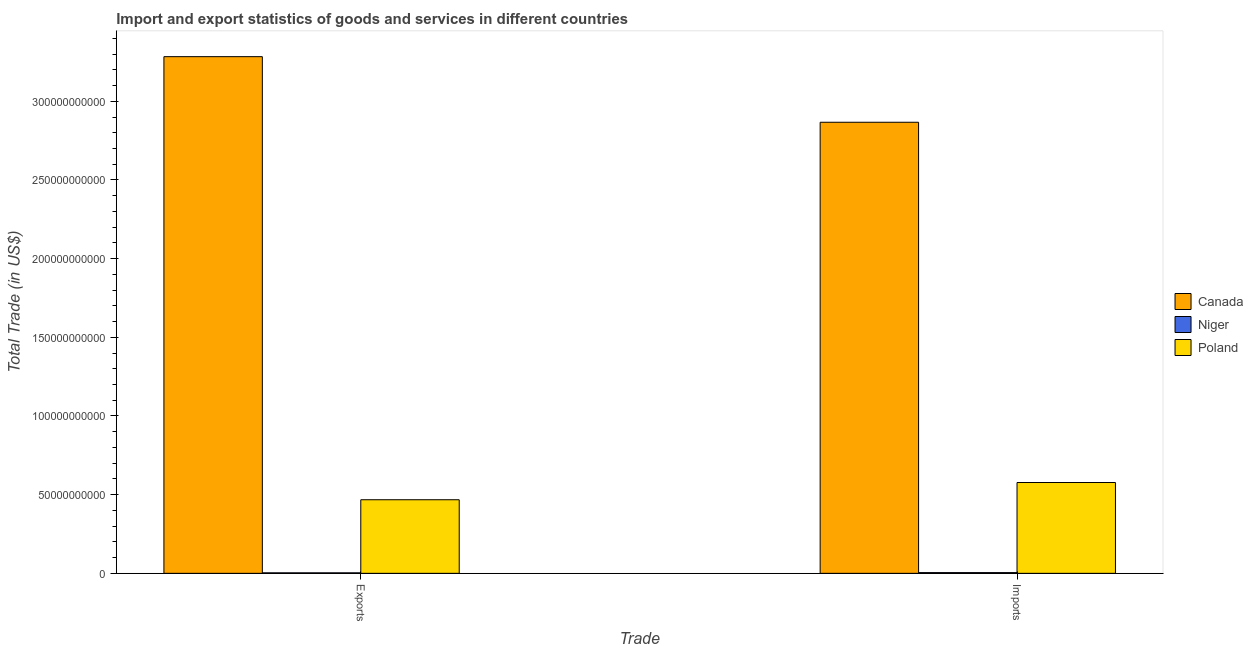How many different coloured bars are there?
Your answer should be very brief. 3. How many groups of bars are there?
Your answer should be compact. 2. How many bars are there on the 1st tick from the right?
Offer a terse response. 3. What is the label of the 1st group of bars from the left?
Keep it short and to the point. Exports. What is the imports of goods and services in Poland?
Your answer should be compact. 5.77e+1. Across all countries, what is the maximum export of goods and services?
Provide a short and direct response. 3.28e+11. Across all countries, what is the minimum imports of goods and services?
Offer a very short reply. 4.62e+08. In which country was the export of goods and services minimum?
Make the answer very short. Niger. What is the total imports of goods and services in the graph?
Your answer should be very brief. 3.45e+11. What is the difference between the export of goods and services in Poland and that in Niger?
Offer a very short reply. 4.65e+1. What is the difference between the imports of goods and services in Poland and the export of goods and services in Canada?
Provide a short and direct response. -2.71e+11. What is the average export of goods and services per country?
Your response must be concise. 1.25e+11. What is the difference between the export of goods and services and imports of goods and services in Canada?
Your answer should be compact. 4.17e+1. What is the ratio of the imports of goods and services in Niger to that in Poland?
Your answer should be very brief. 0.01. In how many countries, is the imports of goods and services greater than the average imports of goods and services taken over all countries?
Your answer should be very brief. 1. What does the 3rd bar from the left in Exports represents?
Keep it short and to the point. Poland. What does the 1st bar from the right in Exports represents?
Make the answer very short. Poland. How many bars are there?
Keep it short and to the point. 6. Are all the bars in the graph horizontal?
Offer a very short reply. No. How many countries are there in the graph?
Keep it short and to the point. 3. Are the values on the major ticks of Y-axis written in scientific E-notation?
Offer a terse response. No. Does the graph contain any zero values?
Provide a succinct answer. No. Where does the legend appear in the graph?
Provide a short and direct response. Center right. How many legend labels are there?
Offer a terse response. 3. What is the title of the graph?
Provide a short and direct response. Import and export statistics of goods and services in different countries. What is the label or title of the X-axis?
Your answer should be compact. Trade. What is the label or title of the Y-axis?
Provide a short and direct response. Total Trade (in US$). What is the Total Trade (in US$) of Canada in Exports?
Provide a succinct answer. 3.28e+11. What is the Total Trade (in US$) in Niger in Exports?
Your answer should be compact. 3.20e+08. What is the Total Trade (in US$) of Poland in Exports?
Give a very brief answer. 4.68e+1. What is the Total Trade (in US$) of Canada in Imports?
Offer a very short reply. 2.87e+11. What is the Total Trade (in US$) of Niger in Imports?
Offer a terse response. 4.62e+08. What is the Total Trade (in US$) of Poland in Imports?
Keep it short and to the point. 5.77e+1. Across all Trade, what is the maximum Total Trade (in US$) in Canada?
Your answer should be compact. 3.28e+11. Across all Trade, what is the maximum Total Trade (in US$) in Niger?
Offer a very short reply. 4.62e+08. Across all Trade, what is the maximum Total Trade (in US$) of Poland?
Your answer should be compact. 5.77e+1. Across all Trade, what is the minimum Total Trade (in US$) in Canada?
Provide a succinct answer. 2.87e+11. Across all Trade, what is the minimum Total Trade (in US$) of Niger?
Offer a very short reply. 3.20e+08. Across all Trade, what is the minimum Total Trade (in US$) in Poland?
Provide a succinct answer. 4.68e+1. What is the total Total Trade (in US$) in Canada in the graph?
Keep it short and to the point. 6.15e+11. What is the total Total Trade (in US$) of Niger in the graph?
Give a very brief answer. 7.82e+08. What is the total Total Trade (in US$) of Poland in the graph?
Provide a short and direct response. 1.04e+11. What is the difference between the Total Trade (in US$) of Canada in Exports and that in Imports?
Ensure brevity in your answer.  4.17e+1. What is the difference between the Total Trade (in US$) of Niger in Exports and that in Imports?
Offer a very short reply. -1.42e+08. What is the difference between the Total Trade (in US$) of Poland in Exports and that in Imports?
Ensure brevity in your answer.  -1.09e+1. What is the difference between the Total Trade (in US$) of Canada in Exports and the Total Trade (in US$) of Niger in Imports?
Provide a succinct answer. 3.28e+11. What is the difference between the Total Trade (in US$) in Canada in Exports and the Total Trade (in US$) in Poland in Imports?
Your answer should be compact. 2.71e+11. What is the difference between the Total Trade (in US$) of Niger in Exports and the Total Trade (in US$) of Poland in Imports?
Your response must be concise. -5.74e+1. What is the average Total Trade (in US$) in Canada per Trade?
Provide a short and direct response. 3.08e+11. What is the average Total Trade (in US$) in Niger per Trade?
Offer a terse response. 3.91e+08. What is the average Total Trade (in US$) of Poland per Trade?
Offer a very short reply. 5.22e+1. What is the difference between the Total Trade (in US$) of Canada and Total Trade (in US$) of Niger in Exports?
Your response must be concise. 3.28e+11. What is the difference between the Total Trade (in US$) of Canada and Total Trade (in US$) of Poland in Exports?
Offer a very short reply. 2.82e+11. What is the difference between the Total Trade (in US$) in Niger and Total Trade (in US$) in Poland in Exports?
Your response must be concise. -4.65e+1. What is the difference between the Total Trade (in US$) of Canada and Total Trade (in US$) of Niger in Imports?
Ensure brevity in your answer.  2.86e+11. What is the difference between the Total Trade (in US$) in Canada and Total Trade (in US$) in Poland in Imports?
Your answer should be compact. 2.29e+11. What is the difference between the Total Trade (in US$) of Niger and Total Trade (in US$) of Poland in Imports?
Make the answer very short. -5.73e+1. What is the ratio of the Total Trade (in US$) of Canada in Exports to that in Imports?
Provide a succinct answer. 1.15. What is the ratio of the Total Trade (in US$) of Niger in Exports to that in Imports?
Offer a terse response. 0.69. What is the ratio of the Total Trade (in US$) in Poland in Exports to that in Imports?
Your response must be concise. 0.81. What is the difference between the highest and the second highest Total Trade (in US$) of Canada?
Your response must be concise. 4.17e+1. What is the difference between the highest and the second highest Total Trade (in US$) of Niger?
Give a very brief answer. 1.42e+08. What is the difference between the highest and the second highest Total Trade (in US$) of Poland?
Your answer should be very brief. 1.09e+1. What is the difference between the highest and the lowest Total Trade (in US$) of Canada?
Provide a succinct answer. 4.17e+1. What is the difference between the highest and the lowest Total Trade (in US$) of Niger?
Keep it short and to the point. 1.42e+08. What is the difference between the highest and the lowest Total Trade (in US$) in Poland?
Keep it short and to the point. 1.09e+1. 